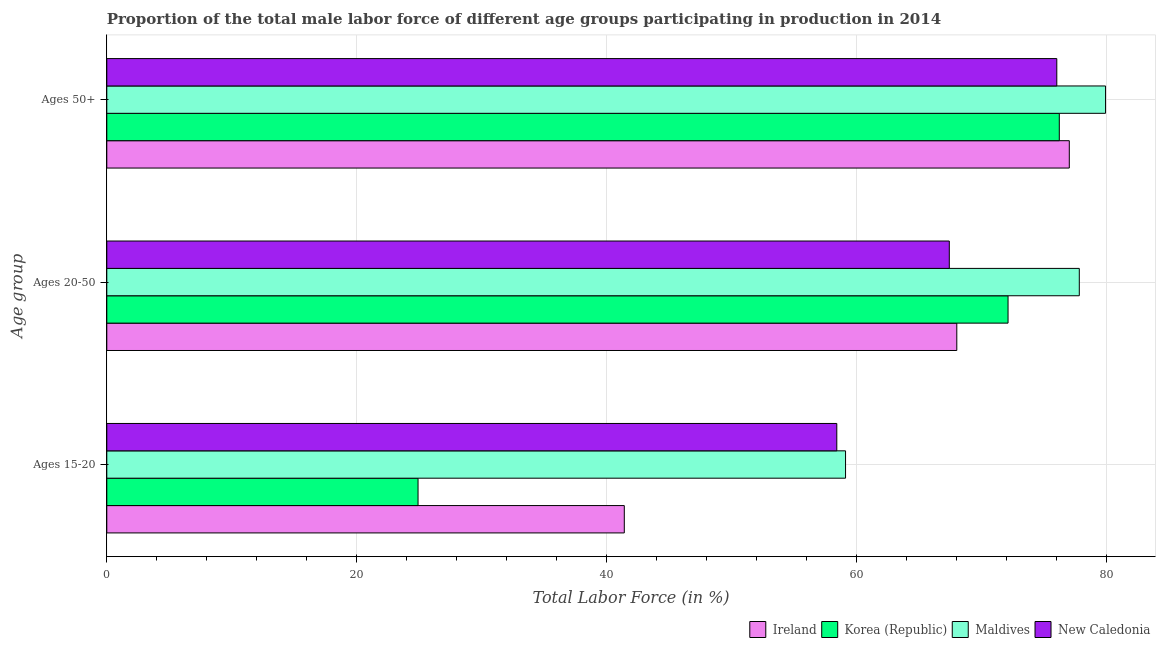How many different coloured bars are there?
Make the answer very short. 4. Are the number of bars per tick equal to the number of legend labels?
Provide a short and direct response. Yes. Are the number of bars on each tick of the Y-axis equal?
Your answer should be very brief. Yes. How many bars are there on the 2nd tick from the top?
Offer a very short reply. 4. How many bars are there on the 2nd tick from the bottom?
Offer a very short reply. 4. What is the label of the 1st group of bars from the top?
Keep it short and to the point. Ages 50+. What is the percentage of male labor force within the age group 20-50 in Korea (Republic)?
Offer a very short reply. 72.1. Across all countries, what is the maximum percentage of male labor force within the age group 20-50?
Offer a terse response. 77.8. In which country was the percentage of male labor force above age 50 maximum?
Provide a succinct answer. Maldives. In which country was the percentage of male labor force within the age group 15-20 minimum?
Give a very brief answer. Korea (Republic). What is the total percentage of male labor force within the age group 15-20 in the graph?
Provide a short and direct response. 183.8. What is the difference between the percentage of male labor force within the age group 20-50 in Korea (Republic) and that in New Caledonia?
Make the answer very short. 4.7. What is the difference between the percentage of male labor force within the age group 20-50 in New Caledonia and the percentage of male labor force above age 50 in Ireland?
Provide a succinct answer. -9.6. What is the average percentage of male labor force within the age group 20-50 per country?
Offer a very short reply. 71.33. What is the difference between the percentage of male labor force within the age group 20-50 and percentage of male labor force within the age group 15-20 in Maldives?
Offer a very short reply. 18.7. What is the ratio of the percentage of male labor force within the age group 20-50 in Maldives to that in New Caledonia?
Your response must be concise. 1.15. What is the difference between the highest and the second highest percentage of male labor force above age 50?
Provide a succinct answer. 2.9. What is the difference between the highest and the lowest percentage of male labor force within the age group 15-20?
Provide a short and direct response. 34.2. What does the 3rd bar from the bottom in Ages 15-20 represents?
Ensure brevity in your answer.  Maldives. Is it the case that in every country, the sum of the percentage of male labor force within the age group 15-20 and percentage of male labor force within the age group 20-50 is greater than the percentage of male labor force above age 50?
Keep it short and to the point. Yes. How many bars are there?
Offer a terse response. 12. Are all the bars in the graph horizontal?
Keep it short and to the point. Yes. How many countries are there in the graph?
Ensure brevity in your answer.  4. What is the difference between two consecutive major ticks on the X-axis?
Ensure brevity in your answer.  20. Does the graph contain any zero values?
Ensure brevity in your answer.  No. Where does the legend appear in the graph?
Your answer should be very brief. Bottom right. What is the title of the graph?
Give a very brief answer. Proportion of the total male labor force of different age groups participating in production in 2014. Does "Uganda" appear as one of the legend labels in the graph?
Offer a very short reply. No. What is the label or title of the Y-axis?
Ensure brevity in your answer.  Age group. What is the Total Labor Force (in %) in Ireland in Ages 15-20?
Provide a short and direct response. 41.4. What is the Total Labor Force (in %) in Korea (Republic) in Ages 15-20?
Keep it short and to the point. 24.9. What is the Total Labor Force (in %) in Maldives in Ages 15-20?
Give a very brief answer. 59.1. What is the Total Labor Force (in %) in New Caledonia in Ages 15-20?
Offer a very short reply. 58.4. What is the Total Labor Force (in %) in Ireland in Ages 20-50?
Ensure brevity in your answer.  68. What is the Total Labor Force (in %) in Korea (Republic) in Ages 20-50?
Your answer should be compact. 72.1. What is the Total Labor Force (in %) of Maldives in Ages 20-50?
Offer a very short reply. 77.8. What is the Total Labor Force (in %) of New Caledonia in Ages 20-50?
Offer a very short reply. 67.4. What is the Total Labor Force (in %) of Korea (Republic) in Ages 50+?
Your answer should be compact. 76.2. What is the Total Labor Force (in %) of Maldives in Ages 50+?
Offer a very short reply. 79.9. What is the Total Labor Force (in %) of New Caledonia in Ages 50+?
Your response must be concise. 76. Across all Age group, what is the maximum Total Labor Force (in %) in Ireland?
Provide a succinct answer. 77. Across all Age group, what is the maximum Total Labor Force (in %) of Korea (Republic)?
Give a very brief answer. 76.2. Across all Age group, what is the maximum Total Labor Force (in %) of Maldives?
Your answer should be very brief. 79.9. Across all Age group, what is the maximum Total Labor Force (in %) in New Caledonia?
Your answer should be very brief. 76. Across all Age group, what is the minimum Total Labor Force (in %) in Ireland?
Your answer should be compact. 41.4. Across all Age group, what is the minimum Total Labor Force (in %) of Korea (Republic)?
Your answer should be very brief. 24.9. Across all Age group, what is the minimum Total Labor Force (in %) of Maldives?
Provide a short and direct response. 59.1. Across all Age group, what is the minimum Total Labor Force (in %) of New Caledonia?
Offer a terse response. 58.4. What is the total Total Labor Force (in %) in Ireland in the graph?
Your answer should be very brief. 186.4. What is the total Total Labor Force (in %) of Korea (Republic) in the graph?
Offer a terse response. 173.2. What is the total Total Labor Force (in %) in Maldives in the graph?
Ensure brevity in your answer.  216.8. What is the total Total Labor Force (in %) of New Caledonia in the graph?
Keep it short and to the point. 201.8. What is the difference between the Total Labor Force (in %) in Ireland in Ages 15-20 and that in Ages 20-50?
Give a very brief answer. -26.6. What is the difference between the Total Labor Force (in %) of Korea (Republic) in Ages 15-20 and that in Ages 20-50?
Offer a very short reply. -47.2. What is the difference between the Total Labor Force (in %) in Maldives in Ages 15-20 and that in Ages 20-50?
Make the answer very short. -18.7. What is the difference between the Total Labor Force (in %) of Ireland in Ages 15-20 and that in Ages 50+?
Provide a short and direct response. -35.6. What is the difference between the Total Labor Force (in %) of Korea (Republic) in Ages 15-20 and that in Ages 50+?
Offer a very short reply. -51.3. What is the difference between the Total Labor Force (in %) of Maldives in Ages 15-20 and that in Ages 50+?
Your answer should be compact. -20.8. What is the difference between the Total Labor Force (in %) of New Caledonia in Ages 15-20 and that in Ages 50+?
Your answer should be compact. -17.6. What is the difference between the Total Labor Force (in %) of Korea (Republic) in Ages 20-50 and that in Ages 50+?
Make the answer very short. -4.1. What is the difference between the Total Labor Force (in %) of Ireland in Ages 15-20 and the Total Labor Force (in %) of Korea (Republic) in Ages 20-50?
Provide a succinct answer. -30.7. What is the difference between the Total Labor Force (in %) of Ireland in Ages 15-20 and the Total Labor Force (in %) of Maldives in Ages 20-50?
Make the answer very short. -36.4. What is the difference between the Total Labor Force (in %) of Korea (Republic) in Ages 15-20 and the Total Labor Force (in %) of Maldives in Ages 20-50?
Offer a terse response. -52.9. What is the difference between the Total Labor Force (in %) of Korea (Republic) in Ages 15-20 and the Total Labor Force (in %) of New Caledonia in Ages 20-50?
Offer a terse response. -42.5. What is the difference between the Total Labor Force (in %) in Maldives in Ages 15-20 and the Total Labor Force (in %) in New Caledonia in Ages 20-50?
Offer a very short reply. -8.3. What is the difference between the Total Labor Force (in %) in Ireland in Ages 15-20 and the Total Labor Force (in %) in Korea (Republic) in Ages 50+?
Provide a short and direct response. -34.8. What is the difference between the Total Labor Force (in %) of Ireland in Ages 15-20 and the Total Labor Force (in %) of Maldives in Ages 50+?
Offer a very short reply. -38.5. What is the difference between the Total Labor Force (in %) in Ireland in Ages 15-20 and the Total Labor Force (in %) in New Caledonia in Ages 50+?
Make the answer very short. -34.6. What is the difference between the Total Labor Force (in %) in Korea (Republic) in Ages 15-20 and the Total Labor Force (in %) in Maldives in Ages 50+?
Keep it short and to the point. -55. What is the difference between the Total Labor Force (in %) of Korea (Republic) in Ages 15-20 and the Total Labor Force (in %) of New Caledonia in Ages 50+?
Provide a succinct answer. -51.1. What is the difference between the Total Labor Force (in %) of Maldives in Ages 15-20 and the Total Labor Force (in %) of New Caledonia in Ages 50+?
Provide a succinct answer. -16.9. What is the difference between the Total Labor Force (in %) of Korea (Republic) in Ages 20-50 and the Total Labor Force (in %) of Maldives in Ages 50+?
Your answer should be very brief. -7.8. What is the difference between the Total Labor Force (in %) in Maldives in Ages 20-50 and the Total Labor Force (in %) in New Caledonia in Ages 50+?
Your answer should be very brief. 1.8. What is the average Total Labor Force (in %) in Ireland per Age group?
Make the answer very short. 62.13. What is the average Total Labor Force (in %) in Korea (Republic) per Age group?
Give a very brief answer. 57.73. What is the average Total Labor Force (in %) in Maldives per Age group?
Your response must be concise. 72.27. What is the average Total Labor Force (in %) of New Caledonia per Age group?
Offer a terse response. 67.27. What is the difference between the Total Labor Force (in %) in Ireland and Total Labor Force (in %) in Korea (Republic) in Ages 15-20?
Keep it short and to the point. 16.5. What is the difference between the Total Labor Force (in %) of Ireland and Total Labor Force (in %) of Maldives in Ages 15-20?
Your answer should be very brief. -17.7. What is the difference between the Total Labor Force (in %) of Korea (Republic) and Total Labor Force (in %) of Maldives in Ages 15-20?
Ensure brevity in your answer.  -34.2. What is the difference between the Total Labor Force (in %) of Korea (Republic) and Total Labor Force (in %) of New Caledonia in Ages 15-20?
Keep it short and to the point. -33.5. What is the difference between the Total Labor Force (in %) in Ireland and Total Labor Force (in %) in New Caledonia in Ages 20-50?
Your answer should be compact. 0.6. What is the difference between the Total Labor Force (in %) of Korea (Republic) and Total Labor Force (in %) of Maldives in Ages 20-50?
Provide a succinct answer. -5.7. What is the difference between the Total Labor Force (in %) in Korea (Republic) and Total Labor Force (in %) in New Caledonia in Ages 20-50?
Keep it short and to the point. 4.7. What is the difference between the Total Labor Force (in %) of Maldives and Total Labor Force (in %) of New Caledonia in Ages 20-50?
Make the answer very short. 10.4. What is the ratio of the Total Labor Force (in %) in Ireland in Ages 15-20 to that in Ages 20-50?
Keep it short and to the point. 0.61. What is the ratio of the Total Labor Force (in %) in Korea (Republic) in Ages 15-20 to that in Ages 20-50?
Provide a short and direct response. 0.35. What is the ratio of the Total Labor Force (in %) in Maldives in Ages 15-20 to that in Ages 20-50?
Provide a short and direct response. 0.76. What is the ratio of the Total Labor Force (in %) in New Caledonia in Ages 15-20 to that in Ages 20-50?
Make the answer very short. 0.87. What is the ratio of the Total Labor Force (in %) in Ireland in Ages 15-20 to that in Ages 50+?
Offer a very short reply. 0.54. What is the ratio of the Total Labor Force (in %) of Korea (Republic) in Ages 15-20 to that in Ages 50+?
Provide a short and direct response. 0.33. What is the ratio of the Total Labor Force (in %) of Maldives in Ages 15-20 to that in Ages 50+?
Your answer should be compact. 0.74. What is the ratio of the Total Labor Force (in %) of New Caledonia in Ages 15-20 to that in Ages 50+?
Offer a terse response. 0.77. What is the ratio of the Total Labor Force (in %) of Ireland in Ages 20-50 to that in Ages 50+?
Your response must be concise. 0.88. What is the ratio of the Total Labor Force (in %) in Korea (Republic) in Ages 20-50 to that in Ages 50+?
Your answer should be very brief. 0.95. What is the ratio of the Total Labor Force (in %) of Maldives in Ages 20-50 to that in Ages 50+?
Offer a very short reply. 0.97. What is the ratio of the Total Labor Force (in %) in New Caledonia in Ages 20-50 to that in Ages 50+?
Offer a very short reply. 0.89. What is the difference between the highest and the second highest Total Labor Force (in %) in Korea (Republic)?
Your response must be concise. 4.1. What is the difference between the highest and the second highest Total Labor Force (in %) in New Caledonia?
Offer a terse response. 8.6. What is the difference between the highest and the lowest Total Labor Force (in %) of Ireland?
Offer a very short reply. 35.6. What is the difference between the highest and the lowest Total Labor Force (in %) of Korea (Republic)?
Offer a terse response. 51.3. What is the difference between the highest and the lowest Total Labor Force (in %) in Maldives?
Provide a short and direct response. 20.8. 